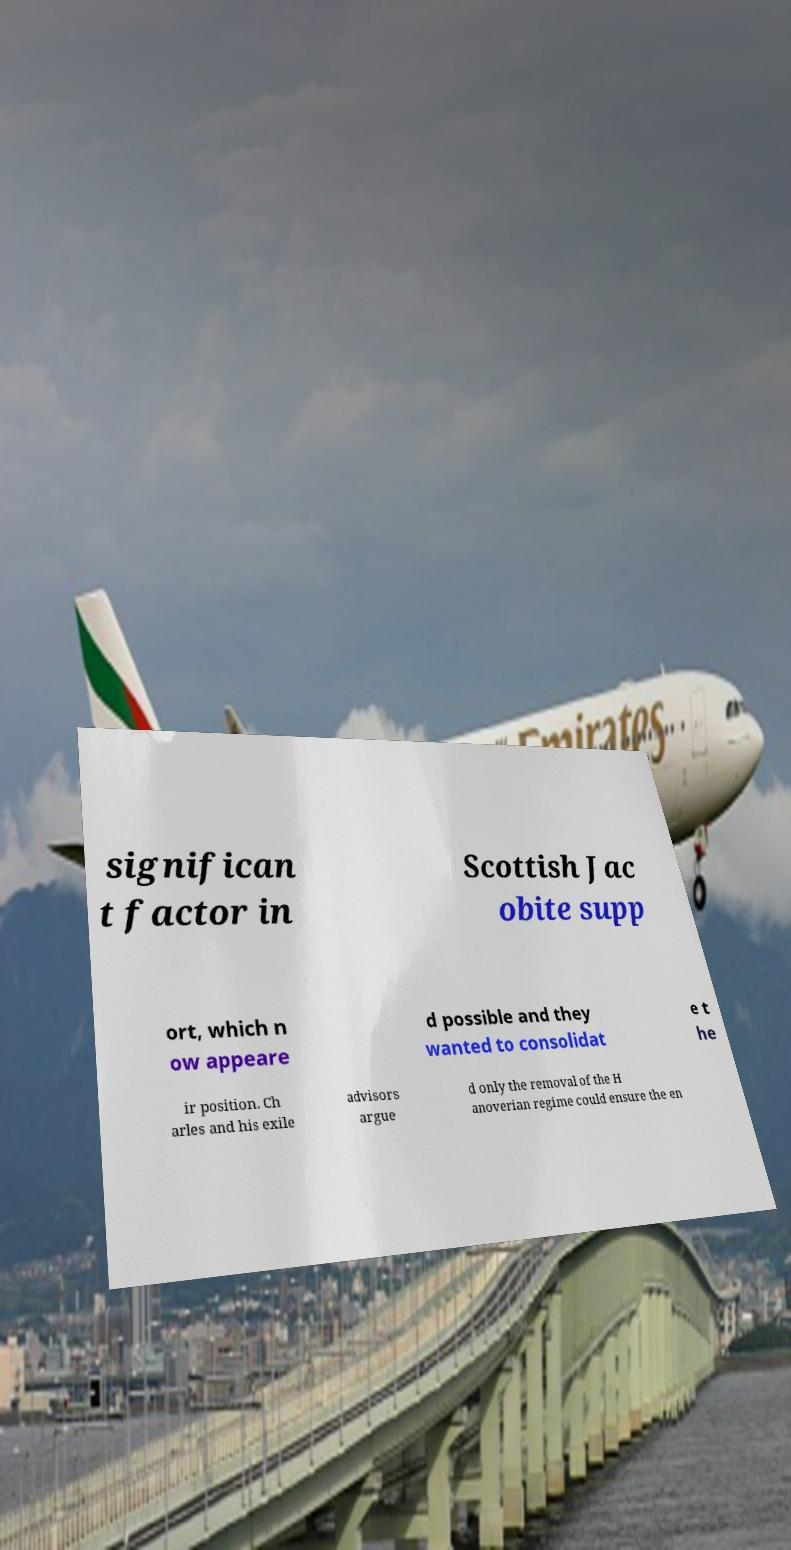What messages or text are displayed in this image? I need them in a readable, typed format. significan t factor in Scottish Jac obite supp ort, which n ow appeare d possible and they wanted to consolidat e t he ir position. Ch arles and his exile advisors argue d only the removal of the H anoverian regime could ensure the en 